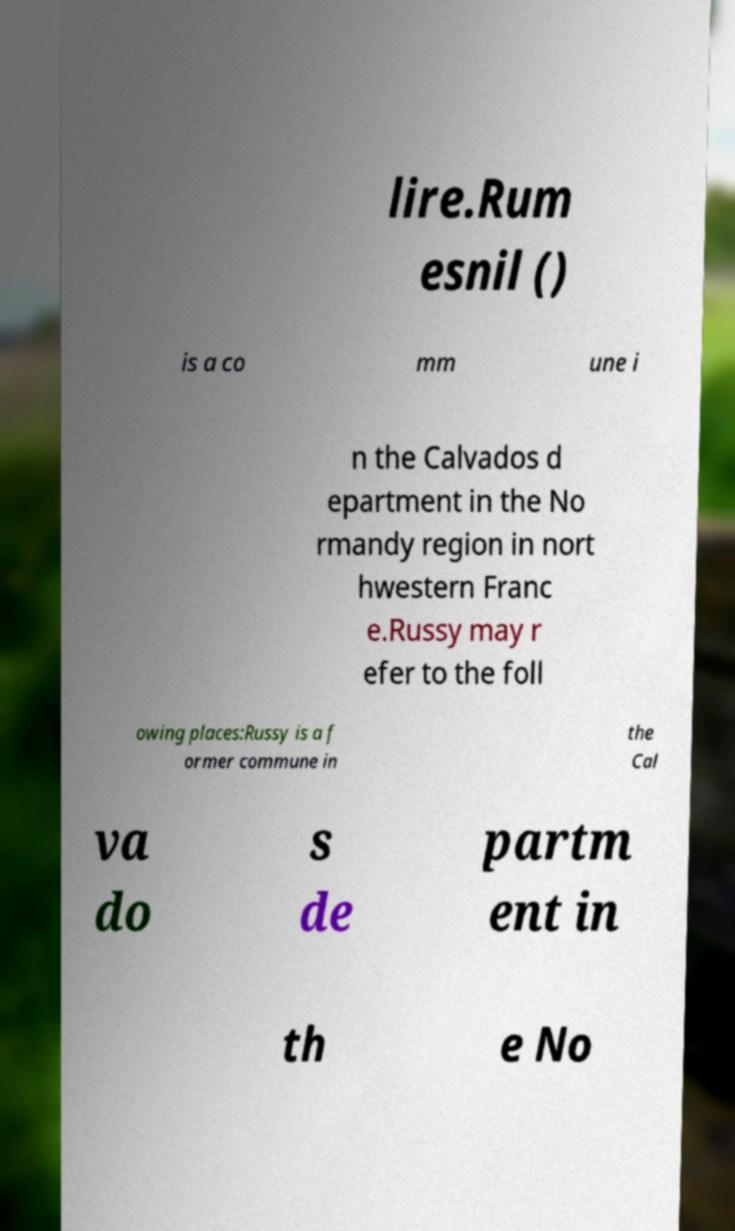Could you assist in decoding the text presented in this image and type it out clearly? lire.Rum esnil () is a co mm une i n the Calvados d epartment in the No rmandy region in nort hwestern Franc e.Russy may r efer to the foll owing places:Russy is a f ormer commune in the Cal va do s de partm ent in th e No 